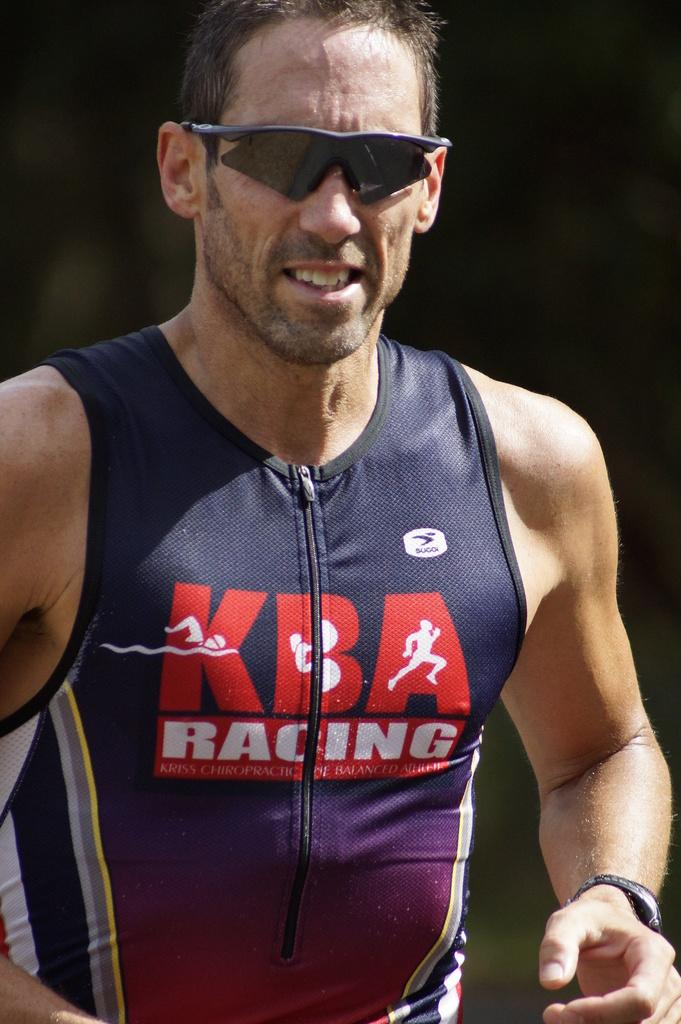<image>
Summarize the visual content of the image. A man with sunglasses on is running and his athletic wear says KBA Racing. 